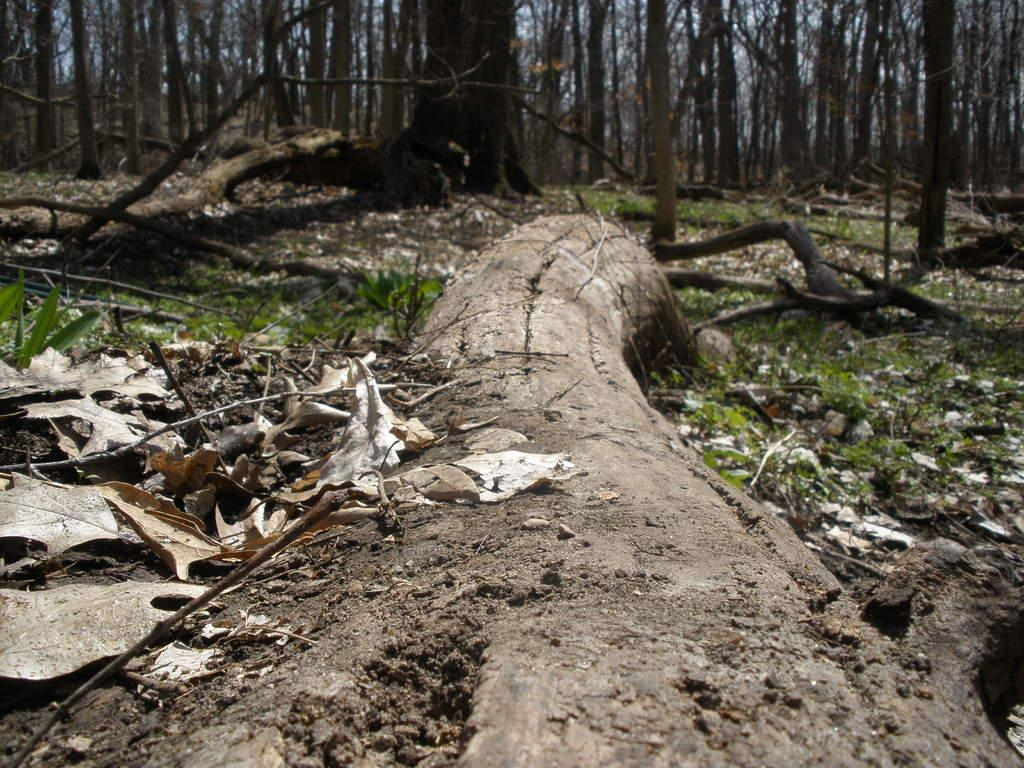What type of tree trunk is on the ground in the image? There is a dry tree trunk on the ground in the image. What else can be seen on the ground besides the tree trunk? There are dry leaves and dry grass on the ground. What can be seen in the background of the image? There are multiple tree trunks visible in the background. How does the snail draw attention to itself in the image? There is no snail present in the image, so it cannot draw attention to itself. 